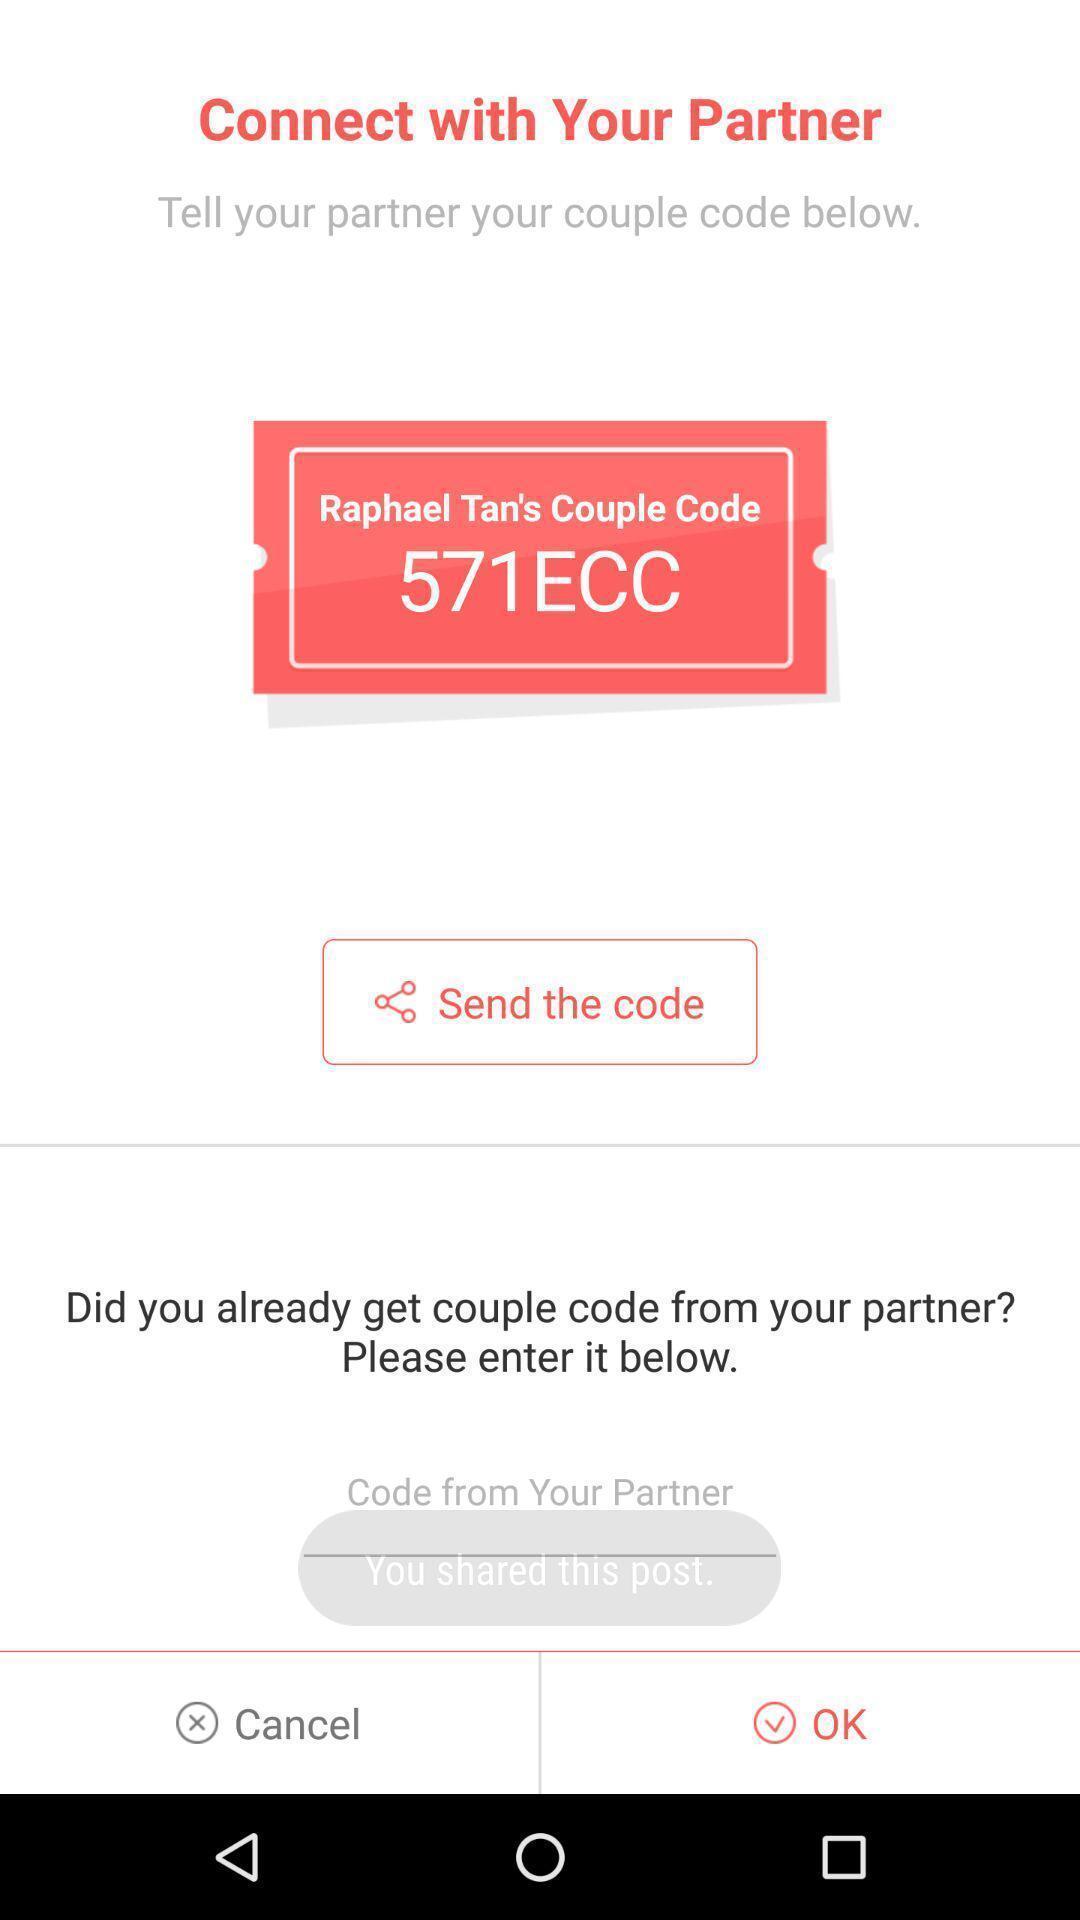Provide a textual representation of this image. Social app for dating and chatting. 